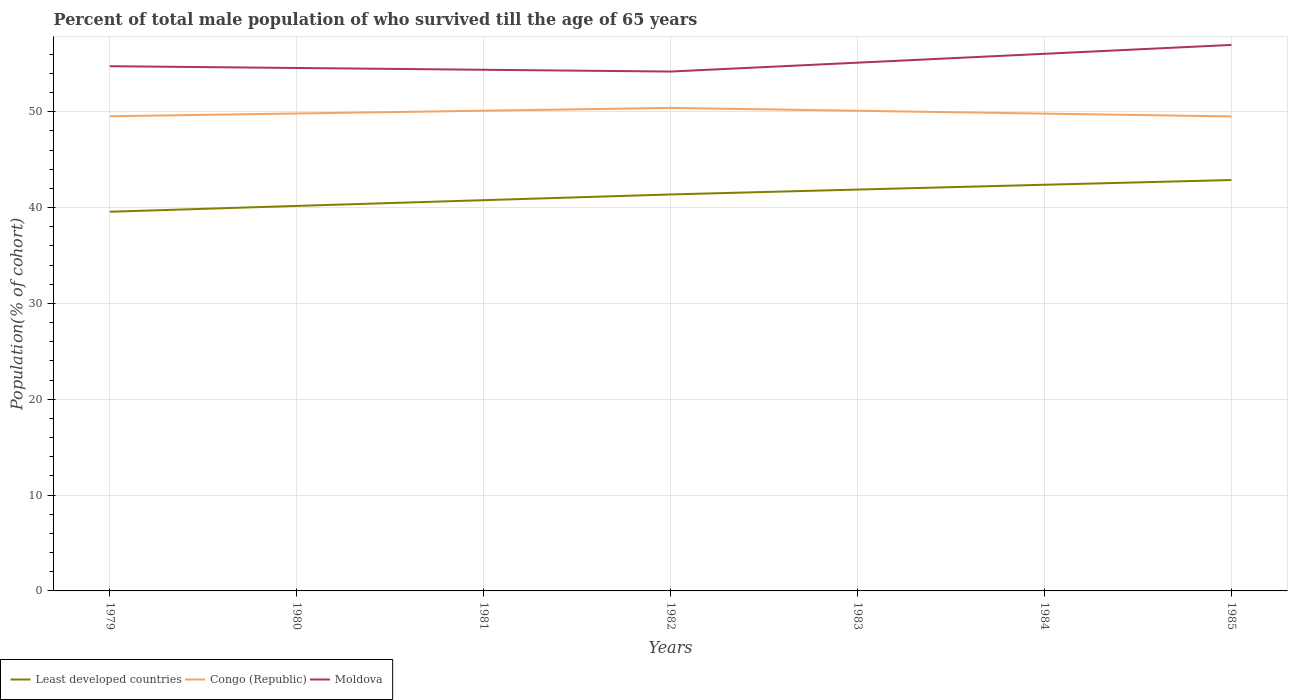How many different coloured lines are there?
Provide a succinct answer. 3. Does the line corresponding to Least developed countries intersect with the line corresponding to Moldova?
Offer a very short reply. No. Across all years, what is the maximum percentage of total male population who survived till the age of 65 years in Moldova?
Your answer should be compact. 54.19. What is the total percentage of total male population who survived till the age of 65 years in Moldova in the graph?
Your response must be concise. 0.56. What is the difference between the highest and the second highest percentage of total male population who survived till the age of 65 years in Congo (Republic)?
Provide a succinct answer. 0.89. What is the difference between the highest and the lowest percentage of total male population who survived till the age of 65 years in Moldova?
Your answer should be compact. 2. How many lines are there?
Offer a terse response. 3. How many years are there in the graph?
Provide a succinct answer. 7. What is the difference between two consecutive major ticks on the Y-axis?
Provide a succinct answer. 10. Does the graph contain any zero values?
Make the answer very short. No. How many legend labels are there?
Offer a very short reply. 3. What is the title of the graph?
Your answer should be compact. Percent of total male population of who survived till the age of 65 years. What is the label or title of the X-axis?
Ensure brevity in your answer.  Years. What is the label or title of the Y-axis?
Offer a very short reply. Population(% of cohort). What is the Population(% of cohort) of Least developed countries in 1979?
Make the answer very short. 39.56. What is the Population(% of cohort) of Congo (Republic) in 1979?
Offer a terse response. 49.53. What is the Population(% of cohort) in Moldova in 1979?
Provide a succinct answer. 54.75. What is the Population(% of cohort) in Least developed countries in 1980?
Give a very brief answer. 40.17. What is the Population(% of cohort) in Congo (Republic) in 1980?
Your answer should be compact. 49.82. What is the Population(% of cohort) of Moldova in 1980?
Provide a succinct answer. 54.57. What is the Population(% of cohort) of Least developed countries in 1981?
Provide a succinct answer. 40.77. What is the Population(% of cohort) in Congo (Republic) in 1981?
Keep it short and to the point. 50.11. What is the Population(% of cohort) of Moldova in 1981?
Your answer should be compact. 54.38. What is the Population(% of cohort) in Least developed countries in 1982?
Ensure brevity in your answer.  41.37. What is the Population(% of cohort) of Congo (Republic) in 1982?
Provide a short and direct response. 50.4. What is the Population(% of cohort) in Moldova in 1982?
Provide a succinct answer. 54.19. What is the Population(% of cohort) of Least developed countries in 1983?
Keep it short and to the point. 41.88. What is the Population(% of cohort) of Congo (Republic) in 1983?
Make the answer very short. 50.1. What is the Population(% of cohort) in Moldova in 1983?
Make the answer very short. 55.12. What is the Population(% of cohort) of Least developed countries in 1984?
Provide a short and direct response. 42.38. What is the Population(% of cohort) in Congo (Republic) in 1984?
Your answer should be compact. 49.8. What is the Population(% of cohort) of Moldova in 1984?
Your answer should be compact. 56.05. What is the Population(% of cohort) of Least developed countries in 1985?
Your answer should be very brief. 42.88. What is the Population(% of cohort) in Congo (Republic) in 1985?
Give a very brief answer. 49.51. What is the Population(% of cohort) in Moldova in 1985?
Keep it short and to the point. 56.97. Across all years, what is the maximum Population(% of cohort) in Least developed countries?
Provide a succinct answer. 42.88. Across all years, what is the maximum Population(% of cohort) in Congo (Republic)?
Provide a short and direct response. 50.4. Across all years, what is the maximum Population(% of cohort) in Moldova?
Ensure brevity in your answer.  56.97. Across all years, what is the minimum Population(% of cohort) of Least developed countries?
Your answer should be compact. 39.56. Across all years, what is the minimum Population(% of cohort) in Congo (Republic)?
Offer a terse response. 49.51. Across all years, what is the minimum Population(% of cohort) in Moldova?
Your response must be concise. 54.19. What is the total Population(% of cohort) of Least developed countries in the graph?
Your answer should be compact. 289.01. What is the total Population(% of cohort) in Congo (Republic) in the graph?
Your answer should be very brief. 349.26. What is the total Population(% of cohort) of Moldova in the graph?
Keep it short and to the point. 386.03. What is the difference between the Population(% of cohort) of Least developed countries in 1979 and that in 1980?
Ensure brevity in your answer.  -0.61. What is the difference between the Population(% of cohort) of Congo (Republic) in 1979 and that in 1980?
Your answer should be compact. -0.29. What is the difference between the Population(% of cohort) in Moldova in 1979 and that in 1980?
Offer a terse response. 0.19. What is the difference between the Population(% of cohort) of Least developed countries in 1979 and that in 1981?
Keep it short and to the point. -1.21. What is the difference between the Population(% of cohort) of Congo (Republic) in 1979 and that in 1981?
Offer a terse response. -0.58. What is the difference between the Population(% of cohort) of Moldova in 1979 and that in 1981?
Give a very brief answer. 0.37. What is the difference between the Population(% of cohort) of Least developed countries in 1979 and that in 1982?
Provide a short and direct response. -1.8. What is the difference between the Population(% of cohort) of Congo (Republic) in 1979 and that in 1982?
Your answer should be compact. -0.87. What is the difference between the Population(% of cohort) in Moldova in 1979 and that in 1982?
Keep it short and to the point. 0.56. What is the difference between the Population(% of cohort) in Least developed countries in 1979 and that in 1983?
Offer a terse response. -2.31. What is the difference between the Population(% of cohort) of Congo (Republic) in 1979 and that in 1983?
Your response must be concise. -0.57. What is the difference between the Population(% of cohort) in Moldova in 1979 and that in 1983?
Offer a terse response. -0.37. What is the difference between the Population(% of cohort) in Least developed countries in 1979 and that in 1984?
Your answer should be very brief. -2.82. What is the difference between the Population(% of cohort) in Congo (Republic) in 1979 and that in 1984?
Your answer should be compact. -0.28. What is the difference between the Population(% of cohort) in Moldova in 1979 and that in 1984?
Give a very brief answer. -1.29. What is the difference between the Population(% of cohort) in Least developed countries in 1979 and that in 1985?
Provide a short and direct response. -3.31. What is the difference between the Population(% of cohort) in Congo (Republic) in 1979 and that in 1985?
Offer a terse response. 0.02. What is the difference between the Population(% of cohort) in Moldova in 1979 and that in 1985?
Make the answer very short. -2.22. What is the difference between the Population(% of cohort) in Least developed countries in 1980 and that in 1981?
Offer a very short reply. -0.6. What is the difference between the Population(% of cohort) of Congo (Republic) in 1980 and that in 1981?
Offer a terse response. -0.29. What is the difference between the Population(% of cohort) of Moldova in 1980 and that in 1981?
Ensure brevity in your answer.  0.19. What is the difference between the Population(% of cohort) in Least developed countries in 1980 and that in 1982?
Ensure brevity in your answer.  -1.19. What is the difference between the Population(% of cohort) in Congo (Republic) in 1980 and that in 1982?
Provide a short and direct response. -0.58. What is the difference between the Population(% of cohort) in Moldova in 1980 and that in 1982?
Offer a terse response. 0.37. What is the difference between the Population(% of cohort) in Least developed countries in 1980 and that in 1983?
Ensure brevity in your answer.  -1.7. What is the difference between the Population(% of cohort) in Congo (Republic) in 1980 and that in 1983?
Keep it short and to the point. -0.28. What is the difference between the Population(% of cohort) in Moldova in 1980 and that in 1983?
Your answer should be very brief. -0.55. What is the difference between the Population(% of cohort) in Least developed countries in 1980 and that in 1984?
Give a very brief answer. -2.21. What is the difference between the Population(% of cohort) of Congo (Republic) in 1980 and that in 1984?
Your answer should be compact. 0.01. What is the difference between the Population(% of cohort) of Moldova in 1980 and that in 1984?
Give a very brief answer. -1.48. What is the difference between the Population(% of cohort) in Least developed countries in 1980 and that in 1985?
Your response must be concise. -2.7. What is the difference between the Population(% of cohort) of Congo (Republic) in 1980 and that in 1985?
Provide a succinct answer. 0.31. What is the difference between the Population(% of cohort) of Moldova in 1980 and that in 1985?
Provide a succinct answer. -2.41. What is the difference between the Population(% of cohort) in Least developed countries in 1981 and that in 1982?
Offer a very short reply. -0.6. What is the difference between the Population(% of cohort) of Congo (Republic) in 1981 and that in 1982?
Ensure brevity in your answer.  -0.29. What is the difference between the Population(% of cohort) in Moldova in 1981 and that in 1982?
Your answer should be compact. 0.19. What is the difference between the Population(% of cohort) of Least developed countries in 1981 and that in 1983?
Give a very brief answer. -1.11. What is the difference between the Population(% of cohort) in Congo (Republic) in 1981 and that in 1983?
Your response must be concise. 0.01. What is the difference between the Population(% of cohort) of Moldova in 1981 and that in 1983?
Provide a short and direct response. -0.74. What is the difference between the Population(% of cohort) in Least developed countries in 1981 and that in 1984?
Your answer should be very brief. -1.61. What is the difference between the Population(% of cohort) of Congo (Republic) in 1981 and that in 1984?
Your response must be concise. 0.3. What is the difference between the Population(% of cohort) of Moldova in 1981 and that in 1984?
Offer a terse response. -1.67. What is the difference between the Population(% of cohort) of Least developed countries in 1981 and that in 1985?
Make the answer very short. -2.1. What is the difference between the Population(% of cohort) in Congo (Republic) in 1981 and that in 1985?
Ensure brevity in your answer.  0.6. What is the difference between the Population(% of cohort) in Moldova in 1981 and that in 1985?
Your answer should be very brief. -2.59. What is the difference between the Population(% of cohort) of Least developed countries in 1982 and that in 1983?
Provide a short and direct response. -0.51. What is the difference between the Population(% of cohort) of Congo (Republic) in 1982 and that in 1983?
Offer a very short reply. 0.3. What is the difference between the Population(% of cohort) of Moldova in 1982 and that in 1983?
Your response must be concise. -0.93. What is the difference between the Population(% of cohort) of Least developed countries in 1982 and that in 1984?
Your answer should be very brief. -1.01. What is the difference between the Population(% of cohort) of Congo (Republic) in 1982 and that in 1984?
Your answer should be compact. 0.59. What is the difference between the Population(% of cohort) in Moldova in 1982 and that in 1984?
Your answer should be compact. -1.85. What is the difference between the Population(% of cohort) in Least developed countries in 1982 and that in 1985?
Your response must be concise. -1.51. What is the difference between the Population(% of cohort) of Congo (Republic) in 1982 and that in 1985?
Provide a succinct answer. 0.89. What is the difference between the Population(% of cohort) in Moldova in 1982 and that in 1985?
Keep it short and to the point. -2.78. What is the difference between the Population(% of cohort) in Least developed countries in 1983 and that in 1984?
Give a very brief answer. -0.5. What is the difference between the Population(% of cohort) of Congo (Republic) in 1983 and that in 1984?
Keep it short and to the point. 0.3. What is the difference between the Population(% of cohort) in Moldova in 1983 and that in 1984?
Provide a short and direct response. -0.93. What is the difference between the Population(% of cohort) in Least developed countries in 1983 and that in 1985?
Your answer should be very brief. -1. What is the difference between the Population(% of cohort) in Congo (Republic) in 1983 and that in 1985?
Give a very brief answer. 0.59. What is the difference between the Population(% of cohort) of Moldova in 1983 and that in 1985?
Ensure brevity in your answer.  -1.85. What is the difference between the Population(% of cohort) in Least developed countries in 1984 and that in 1985?
Provide a succinct answer. -0.49. What is the difference between the Population(% of cohort) of Congo (Republic) in 1984 and that in 1985?
Make the answer very short. 0.3. What is the difference between the Population(% of cohort) of Moldova in 1984 and that in 1985?
Provide a succinct answer. -0.93. What is the difference between the Population(% of cohort) in Least developed countries in 1979 and the Population(% of cohort) in Congo (Republic) in 1980?
Provide a succinct answer. -10.25. What is the difference between the Population(% of cohort) in Least developed countries in 1979 and the Population(% of cohort) in Moldova in 1980?
Give a very brief answer. -15. What is the difference between the Population(% of cohort) in Congo (Republic) in 1979 and the Population(% of cohort) in Moldova in 1980?
Make the answer very short. -5.04. What is the difference between the Population(% of cohort) of Least developed countries in 1979 and the Population(% of cohort) of Congo (Republic) in 1981?
Make the answer very short. -10.54. What is the difference between the Population(% of cohort) in Least developed countries in 1979 and the Population(% of cohort) in Moldova in 1981?
Ensure brevity in your answer.  -14.82. What is the difference between the Population(% of cohort) in Congo (Republic) in 1979 and the Population(% of cohort) in Moldova in 1981?
Give a very brief answer. -4.85. What is the difference between the Population(% of cohort) in Least developed countries in 1979 and the Population(% of cohort) in Congo (Republic) in 1982?
Make the answer very short. -10.83. What is the difference between the Population(% of cohort) of Least developed countries in 1979 and the Population(% of cohort) of Moldova in 1982?
Provide a short and direct response. -14.63. What is the difference between the Population(% of cohort) in Congo (Republic) in 1979 and the Population(% of cohort) in Moldova in 1982?
Provide a succinct answer. -4.67. What is the difference between the Population(% of cohort) in Least developed countries in 1979 and the Population(% of cohort) in Congo (Republic) in 1983?
Your response must be concise. -10.54. What is the difference between the Population(% of cohort) in Least developed countries in 1979 and the Population(% of cohort) in Moldova in 1983?
Offer a very short reply. -15.56. What is the difference between the Population(% of cohort) in Congo (Republic) in 1979 and the Population(% of cohort) in Moldova in 1983?
Your response must be concise. -5.59. What is the difference between the Population(% of cohort) in Least developed countries in 1979 and the Population(% of cohort) in Congo (Republic) in 1984?
Your response must be concise. -10.24. What is the difference between the Population(% of cohort) in Least developed countries in 1979 and the Population(% of cohort) in Moldova in 1984?
Your response must be concise. -16.48. What is the difference between the Population(% of cohort) in Congo (Republic) in 1979 and the Population(% of cohort) in Moldova in 1984?
Your answer should be very brief. -6.52. What is the difference between the Population(% of cohort) in Least developed countries in 1979 and the Population(% of cohort) in Congo (Republic) in 1985?
Your response must be concise. -9.94. What is the difference between the Population(% of cohort) of Least developed countries in 1979 and the Population(% of cohort) of Moldova in 1985?
Offer a terse response. -17.41. What is the difference between the Population(% of cohort) of Congo (Republic) in 1979 and the Population(% of cohort) of Moldova in 1985?
Provide a short and direct response. -7.45. What is the difference between the Population(% of cohort) of Least developed countries in 1980 and the Population(% of cohort) of Congo (Republic) in 1981?
Your response must be concise. -9.93. What is the difference between the Population(% of cohort) of Least developed countries in 1980 and the Population(% of cohort) of Moldova in 1981?
Offer a very short reply. -14.21. What is the difference between the Population(% of cohort) in Congo (Republic) in 1980 and the Population(% of cohort) in Moldova in 1981?
Your answer should be very brief. -4.56. What is the difference between the Population(% of cohort) in Least developed countries in 1980 and the Population(% of cohort) in Congo (Republic) in 1982?
Your answer should be compact. -10.22. What is the difference between the Population(% of cohort) of Least developed countries in 1980 and the Population(% of cohort) of Moldova in 1982?
Your answer should be very brief. -14.02. What is the difference between the Population(% of cohort) in Congo (Republic) in 1980 and the Population(% of cohort) in Moldova in 1982?
Give a very brief answer. -4.38. What is the difference between the Population(% of cohort) in Least developed countries in 1980 and the Population(% of cohort) in Congo (Republic) in 1983?
Offer a very short reply. -9.93. What is the difference between the Population(% of cohort) in Least developed countries in 1980 and the Population(% of cohort) in Moldova in 1983?
Give a very brief answer. -14.95. What is the difference between the Population(% of cohort) in Congo (Republic) in 1980 and the Population(% of cohort) in Moldova in 1983?
Provide a succinct answer. -5.3. What is the difference between the Population(% of cohort) of Least developed countries in 1980 and the Population(% of cohort) of Congo (Republic) in 1984?
Offer a very short reply. -9.63. What is the difference between the Population(% of cohort) in Least developed countries in 1980 and the Population(% of cohort) in Moldova in 1984?
Give a very brief answer. -15.87. What is the difference between the Population(% of cohort) of Congo (Republic) in 1980 and the Population(% of cohort) of Moldova in 1984?
Your answer should be compact. -6.23. What is the difference between the Population(% of cohort) in Least developed countries in 1980 and the Population(% of cohort) in Congo (Republic) in 1985?
Give a very brief answer. -9.33. What is the difference between the Population(% of cohort) of Least developed countries in 1980 and the Population(% of cohort) of Moldova in 1985?
Keep it short and to the point. -16.8. What is the difference between the Population(% of cohort) of Congo (Republic) in 1980 and the Population(% of cohort) of Moldova in 1985?
Keep it short and to the point. -7.15. What is the difference between the Population(% of cohort) in Least developed countries in 1981 and the Population(% of cohort) in Congo (Republic) in 1982?
Offer a very short reply. -9.62. What is the difference between the Population(% of cohort) of Least developed countries in 1981 and the Population(% of cohort) of Moldova in 1982?
Offer a terse response. -13.42. What is the difference between the Population(% of cohort) in Congo (Republic) in 1981 and the Population(% of cohort) in Moldova in 1982?
Your answer should be very brief. -4.09. What is the difference between the Population(% of cohort) in Least developed countries in 1981 and the Population(% of cohort) in Congo (Republic) in 1983?
Make the answer very short. -9.33. What is the difference between the Population(% of cohort) of Least developed countries in 1981 and the Population(% of cohort) of Moldova in 1983?
Ensure brevity in your answer.  -14.35. What is the difference between the Population(% of cohort) in Congo (Republic) in 1981 and the Population(% of cohort) in Moldova in 1983?
Provide a short and direct response. -5.01. What is the difference between the Population(% of cohort) in Least developed countries in 1981 and the Population(% of cohort) in Congo (Republic) in 1984?
Your response must be concise. -9.03. What is the difference between the Population(% of cohort) in Least developed countries in 1981 and the Population(% of cohort) in Moldova in 1984?
Ensure brevity in your answer.  -15.27. What is the difference between the Population(% of cohort) in Congo (Republic) in 1981 and the Population(% of cohort) in Moldova in 1984?
Provide a succinct answer. -5.94. What is the difference between the Population(% of cohort) in Least developed countries in 1981 and the Population(% of cohort) in Congo (Republic) in 1985?
Provide a short and direct response. -8.74. What is the difference between the Population(% of cohort) of Least developed countries in 1981 and the Population(% of cohort) of Moldova in 1985?
Offer a very short reply. -16.2. What is the difference between the Population(% of cohort) of Congo (Republic) in 1981 and the Population(% of cohort) of Moldova in 1985?
Your answer should be compact. -6.86. What is the difference between the Population(% of cohort) in Least developed countries in 1982 and the Population(% of cohort) in Congo (Republic) in 1983?
Make the answer very short. -8.73. What is the difference between the Population(% of cohort) in Least developed countries in 1982 and the Population(% of cohort) in Moldova in 1983?
Provide a short and direct response. -13.75. What is the difference between the Population(% of cohort) in Congo (Republic) in 1982 and the Population(% of cohort) in Moldova in 1983?
Your answer should be very brief. -4.72. What is the difference between the Population(% of cohort) in Least developed countries in 1982 and the Population(% of cohort) in Congo (Republic) in 1984?
Keep it short and to the point. -8.44. What is the difference between the Population(% of cohort) in Least developed countries in 1982 and the Population(% of cohort) in Moldova in 1984?
Offer a very short reply. -14.68. What is the difference between the Population(% of cohort) of Congo (Republic) in 1982 and the Population(% of cohort) of Moldova in 1984?
Keep it short and to the point. -5.65. What is the difference between the Population(% of cohort) of Least developed countries in 1982 and the Population(% of cohort) of Congo (Republic) in 1985?
Give a very brief answer. -8.14. What is the difference between the Population(% of cohort) in Least developed countries in 1982 and the Population(% of cohort) in Moldova in 1985?
Give a very brief answer. -15.6. What is the difference between the Population(% of cohort) in Congo (Republic) in 1982 and the Population(% of cohort) in Moldova in 1985?
Offer a very short reply. -6.57. What is the difference between the Population(% of cohort) of Least developed countries in 1983 and the Population(% of cohort) of Congo (Republic) in 1984?
Your answer should be very brief. -7.93. What is the difference between the Population(% of cohort) of Least developed countries in 1983 and the Population(% of cohort) of Moldova in 1984?
Offer a very short reply. -14.17. What is the difference between the Population(% of cohort) in Congo (Republic) in 1983 and the Population(% of cohort) in Moldova in 1984?
Make the answer very short. -5.94. What is the difference between the Population(% of cohort) in Least developed countries in 1983 and the Population(% of cohort) in Congo (Republic) in 1985?
Provide a succinct answer. -7.63. What is the difference between the Population(% of cohort) of Least developed countries in 1983 and the Population(% of cohort) of Moldova in 1985?
Your answer should be very brief. -15.09. What is the difference between the Population(% of cohort) of Congo (Republic) in 1983 and the Population(% of cohort) of Moldova in 1985?
Your answer should be compact. -6.87. What is the difference between the Population(% of cohort) in Least developed countries in 1984 and the Population(% of cohort) in Congo (Republic) in 1985?
Offer a very short reply. -7.13. What is the difference between the Population(% of cohort) of Least developed countries in 1984 and the Population(% of cohort) of Moldova in 1985?
Give a very brief answer. -14.59. What is the difference between the Population(% of cohort) in Congo (Republic) in 1984 and the Population(% of cohort) in Moldova in 1985?
Keep it short and to the point. -7.17. What is the average Population(% of cohort) of Least developed countries per year?
Offer a terse response. 41.29. What is the average Population(% of cohort) in Congo (Republic) per year?
Ensure brevity in your answer.  49.89. What is the average Population(% of cohort) in Moldova per year?
Offer a very short reply. 55.15. In the year 1979, what is the difference between the Population(% of cohort) of Least developed countries and Population(% of cohort) of Congo (Republic)?
Your response must be concise. -9.96. In the year 1979, what is the difference between the Population(% of cohort) in Least developed countries and Population(% of cohort) in Moldova?
Offer a very short reply. -15.19. In the year 1979, what is the difference between the Population(% of cohort) of Congo (Republic) and Population(% of cohort) of Moldova?
Provide a succinct answer. -5.22. In the year 1980, what is the difference between the Population(% of cohort) in Least developed countries and Population(% of cohort) in Congo (Republic)?
Offer a very short reply. -9.64. In the year 1980, what is the difference between the Population(% of cohort) in Least developed countries and Population(% of cohort) in Moldova?
Give a very brief answer. -14.39. In the year 1980, what is the difference between the Population(% of cohort) of Congo (Republic) and Population(% of cohort) of Moldova?
Provide a succinct answer. -4.75. In the year 1981, what is the difference between the Population(% of cohort) in Least developed countries and Population(% of cohort) in Congo (Republic)?
Ensure brevity in your answer.  -9.33. In the year 1981, what is the difference between the Population(% of cohort) in Least developed countries and Population(% of cohort) in Moldova?
Your response must be concise. -13.61. In the year 1981, what is the difference between the Population(% of cohort) of Congo (Republic) and Population(% of cohort) of Moldova?
Your response must be concise. -4.27. In the year 1982, what is the difference between the Population(% of cohort) in Least developed countries and Population(% of cohort) in Congo (Republic)?
Your response must be concise. -9.03. In the year 1982, what is the difference between the Population(% of cohort) of Least developed countries and Population(% of cohort) of Moldova?
Offer a terse response. -12.82. In the year 1982, what is the difference between the Population(% of cohort) in Congo (Republic) and Population(% of cohort) in Moldova?
Keep it short and to the point. -3.8. In the year 1983, what is the difference between the Population(% of cohort) in Least developed countries and Population(% of cohort) in Congo (Republic)?
Your answer should be compact. -8.22. In the year 1983, what is the difference between the Population(% of cohort) of Least developed countries and Population(% of cohort) of Moldova?
Your answer should be very brief. -13.24. In the year 1983, what is the difference between the Population(% of cohort) of Congo (Republic) and Population(% of cohort) of Moldova?
Provide a succinct answer. -5.02. In the year 1984, what is the difference between the Population(% of cohort) in Least developed countries and Population(% of cohort) in Congo (Republic)?
Your response must be concise. -7.42. In the year 1984, what is the difference between the Population(% of cohort) of Least developed countries and Population(% of cohort) of Moldova?
Your answer should be very brief. -13.66. In the year 1984, what is the difference between the Population(% of cohort) in Congo (Republic) and Population(% of cohort) in Moldova?
Keep it short and to the point. -6.24. In the year 1985, what is the difference between the Population(% of cohort) of Least developed countries and Population(% of cohort) of Congo (Republic)?
Your answer should be compact. -6.63. In the year 1985, what is the difference between the Population(% of cohort) in Least developed countries and Population(% of cohort) in Moldova?
Make the answer very short. -14.1. In the year 1985, what is the difference between the Population(% of cohort) in Congo (Republic) and Population(% of cohort) in Moldova?
Give a very brief answer. -7.46. What is the ratio of the Population(% of cohort) in Congo (Republic) in 1979 to that in 1980?
Your response must be concise. 0.99. What is the ratio of the Population(% of cohort) of Least developed countries in 1979 to that in 1981?
Offer a terse response. 0.97. What is the ratio of the Population(% of cohort) in Congo (Republic) in 1979 to that in 1981?
Offer a very short reply. 0.99. What is the ratio of the Population(% of cohort) in Moldova in 1979 to that in 1981?
Your response must be concise. 1.01. What is the ratio of the Population(% of cohort) in Least developed countries in 1979 to that in 1982?
Your answer should be very brief. 0.96. What is the ratio of the Population(% of cohort) in Congo (Republic) in 1979 to that in 1982?
Offer a terse response. 0.98. What is the ratio of the Population(% of cohort) in Moldova in 1979 to that in 1982?
Offer a terse response. 1.01. What is the ratio of the Population(% of cohort) of Least developed countries in 1979 to that in 1983?
Provide a short and direct response. 0.94. What is the ratio of the Population(% of cohort) of Moldova in 1979 to that in 1983?
Offer a very short reply. 0.99. What is the ratio of the Population(% of cohort) in Least developed countries in 1979 to that in 1984?
Keep it short and to the point. 0.93. What is the ratio of the Population(% of cohort) of Congo (Republic) in 1979 to that in 1984?
Keep it short and to the point. 0.99. What is the ratio of the Population(% of cohort) of Moldova in 1979 to that in 1984?
Offer a very short reply. 0.98. What is the ratio of the Population(% of cohort) of Least developed countries in 1979 to that in 1985?
Give a very brief answer. 0.92. What is the ratio of the Population(% of cohort) of Moldova in 1979 to that in 1985?
Make the answer very short. 0.96. What is the ratio of the Population(% of cohort) in Least developed countries in 1980 to that in 1981?
Make the answer very short. 0.99. What is the ratio of the Population(% of cohort) in Least developed countries in 1980 to that in 1982?
Provide a short and direct response. 0.97. What is the ratio of the Population(% of cohort) of Congo (Republic) in 1980 to that in 1982?
Offer a terse response. 0.99. What is the ratio of the Population(% of cohort) of Least developed countries in 1980 to that in 1983?
Offer a very short reply. 0.96. What is the ratio of the Population(% of cohort) in Least developed countries in 1980 to that in 1984?
Offer a very short reply. 0.95. What is the ratio of the Population(% of cohort) in Congo (Republic) in 1980 to that in 1984?
Your response must be concise. 1. What is the ratio of the Population(% of cohort) in Moldova in 1980 to that in 1984?
Keep it short and to the point. 0.97. What is the ratio of the Population(% of cohort) of Least developed countries in 1980 to that in 1985?
Provide a succinct answer. 0.94. What is the ratio of the Population(% of cohort) of Congo (Republic) in 1980 to that in 1985?
Keep it short and to the point. 1.01. What is the ratio of the Population(% of cohort) of Moldova in 1980 to that in 1985?
Make the answer very short. 0.96. What is the ratio of the Population(% of cohort) in Least developed countries in 1981 to that in 1982?
Offer a very short reply. 0.99. What is the ratio of the Population(% of cohort) in Least developed countries in 1981 to that in 1983?
Provide a succinct answer. 0.97. What is the ratio of the Population(% of cohort) of Congo (Republic) in 1981 to that in 1983?
Offer a very short reply. 1. What is the ratio of the Population(% of cohort) in Moldova in 1981 to that in 1983?
Make the answer very short. 0.99. What is the ratio of the Population(% of cohort) of Congo (Republic) in 1981 to that in 1984?
Make the answer very short. 1.01. What is the ratio of the Population(% of cohort) of Moldova in 1981 to that in 1984?
Make the answer very short. 0.97. What is the ratio of the Population(% of cohort) in Least developed countries in 1981 to that in 1985?
Your response must be concise. 0.95. What is the ratio of the Population(% of cohort) in Congo (Republic) in 1981 to that in 1985?
Keep it short and to the point. 1.01. What is the ratio of the Population(% of cohort) of Moldova in 1981 to that in 1985?
Offer a terse response. 0.95. What is the ratio of the Population(% of cohort) of Least developed countries in 1982 to that in 1983?
Offer a terse response. 0.99. What is the ratio of the Population(% of cohort) of Congo (Republic) in 1982 to that in 1983?
Provide a succinct answer. 1.01. What is the ratio of the Population(% of cohort) of Moldova in 1982 to that in 1983?
Provide a short and direct response. 0.98. What is the ratio of the Population(% of cohort) of Least developed countries in 1982 to that in 1984?
Give a very brief answer. 0.98. What is the ratio of the Population(% of cohort) in Congo (Republic) in 1982 to that in 1984?
Your answer should be compact. 1.01. What is the ratio of the Population(% of cohort) in Moldova in 1982 to that in 1984?
Your answer should be very brief. 0.97. What is the ratio of the Population(% of cohort) of Least developed countries in 1982 to that in 1985?
Provide a short and direct response. 0.96. What is the ratio of the Population(% of cohort) in Congo (Republic) in 1982 to that in 1985?
Ensure brevity in your answer.  1.02. What is the ratio of the Population(% of cohort) in Moldova in 1982 to that in 1985?
Provide a short and direct response. 0.95. What is the ratio of the Population(% of cohort) in Least developed countries in 1983 to that in 1984?
Make the answer very short. 0.99. What is the ratio of the Population(% of cohort) of Moldova in 1983 to that in 1984?
Provide a succinct answer. 0.98. What is the ratio of the Population(% of cohort) in Least developed countries in 1983 to that in 1985?
Your answer should be very brief. 0.98. What is the ratio of the Population(% of cohort) of Moldova in 1983 to that in 1985?
Provide a succinct answer. 0.97. What is the ratio of the Population(% of cohort) of Moldova in 1984 to that in 1985?
Make the answer very short. 0.98. What is the difference between the highest and the second highest Population(% of cohort) in Least developed countries?
Give a very brief answer. 0.49. What is the difference between the highest and the second highest Population(% of cohort) of Congo (Republic)?
Provide a succinct answer. 0.29. What is the difference between the highest and the second highest Population(% of cohort) of Moldova?
Give a very brief answer. 0.93. What is the difference between the highest and the lowest Population(% of cohort) in Least developed countries?
Provide a succinct answer. 3.31. What is the difference between the highest and the lowest Population(% of cohort) of Congo (Republic)?
Make the answer very short. 0.89. What is the difference between the highest and the lowest Population(% of cohort) of Moldova?
Offer a terse response. 2.78. 